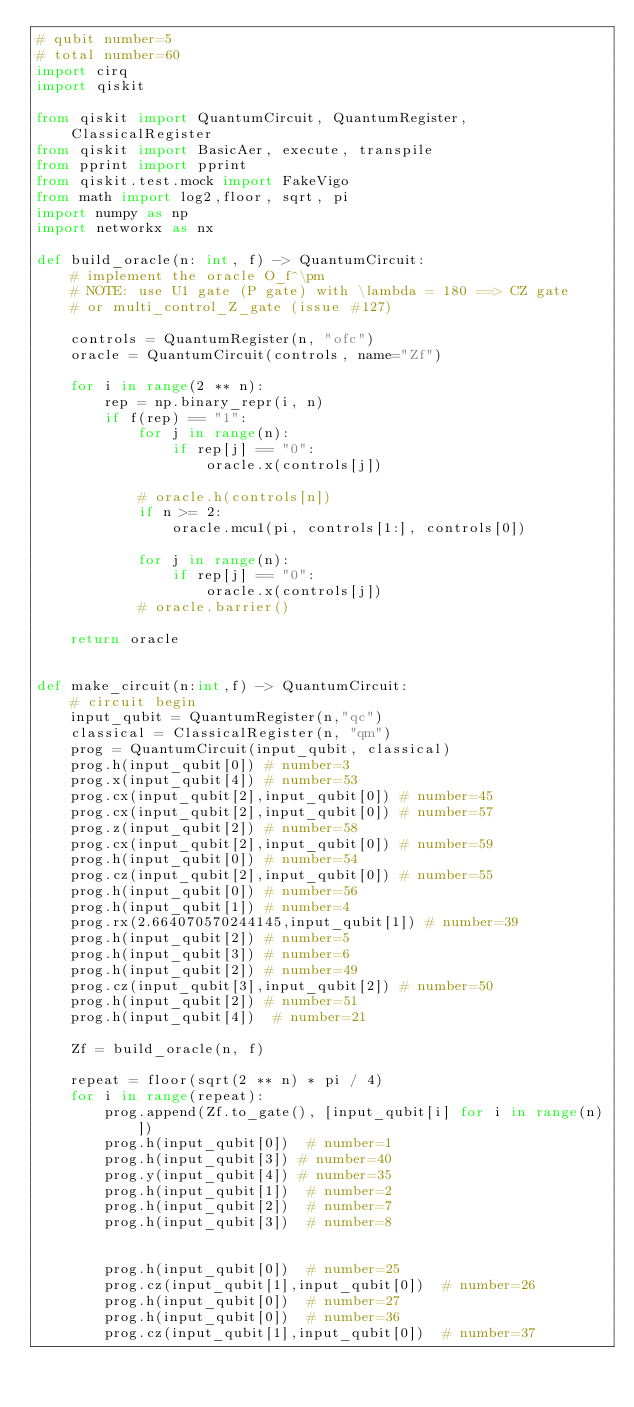<code> <loc_0><loc_0><loc_500><loc_500><_Python_># qubit number=5
# total number=60
import cirq
import qiskit

from qiskit import QuantumCircuit, QuantumRegister, ClassicalRegister
from qiskit import BasicAer, execute, transpile
from pprint import pprint
from qiskit.test.mock import FakeVigo
from math import log2,floor, sqrt, pi
import numpy as np
import networkx as nx

def build_oracle(n: int, f) -> QuantumCircuit:
    # implement the oracle O_f^\pm
    # NOTE: use U1 gate (P gate) with \lambda = 180 ==> CZ gate
    # or multi_control_Z_gate (issue #127)

    controls = QuantumRegister(n, "ofc")
    oracle = QuantumCircuit(controls, name="Zf")

    for i in range(2 ** n):
        rep = np.binary_repr(i, n)
        if f(rep) == "1":
            for j in range(n):
                if rep[j] == "0":
                    oracle.x(controls[j])

            # oracle.h(controls[n])
            if n >= 2:
                oracle.mcu1(pi, controls[1:], controls[0])

            for j in range(n):
                if rep[j] == "0":
                    oracle.x(controls[j])
            # oracle.barrier()

    return oracle


def make_circuit(n:int,f) -> QuantumCircuit:
    # circuit begin
    input_qubit = QuantumRegister(n,"qc")
    classical = ClassicalRegister(n, "qm")
    prog = QuantumCircuit(input_qubit, classical)
    prog.h(input_qubit[0]) # number=3
    prog.x(input_qubit[4]) # number=53
    prog.cx(input_qubit[2],input_qubit[0]) # number=45
    prog.cx(input_qubit[2],input_qubit[0]) # number=57
    prog.z(input_qubit[2]) # number=58
    prog.cx(input_qubit[2],input_qubit[0]) # number=59
    prog.h(input_qubit[0]) # number=54
    prog.cz(input_qubit[2],input_qubit[0]) # number=55
    prog.h(input_qubit[0]) # number=56
    prog.h(input_qubit[1]) # number=4
    prog.rx(2.664070570244145,input_qubit[1]) # number=39
    prog.h(input_qubit[2]) # number=5
    prog.h(input_qubit[3]) # number=6
    prog.h(input_qubit[2]) # number=49
    prog.cz(input_qubit[3],input_qubit[2]) # number=50
    prog.h(input_qubit[2]) # number=51
    prog.h(input_qubit[4])  # number=21

    Zf = build_oracle(n, f)

    repeat = floor(sqrt(2 ** n) * pi / 4)
    for i in range(repeat):
        prog.append(Zf.to_gate(), [input_qubit[i] for i in range(n)])
        prog.h(input_qubit[0])  # number=1
        prog.h(input_qubit[3]) # number=40
        prog.y(input_qubit[4]) # number=35
        prog.h(input_qubit[1])  # number=2
        prog.h(input_qubit[2])  # number=7
        prog.h(input_qubit[3])  # number=8


        prog.h(input_qubit[0])  # number=25
        prog.cz(input_qubit[1],input_qubit[0])  # number=26
        prog.h(input_qubit[0])  # number=27
        prog.h(input_qubit[0])  # number=36
        prog.cz(input_qubit[1],input_qubit[0])  # number=37</code> 